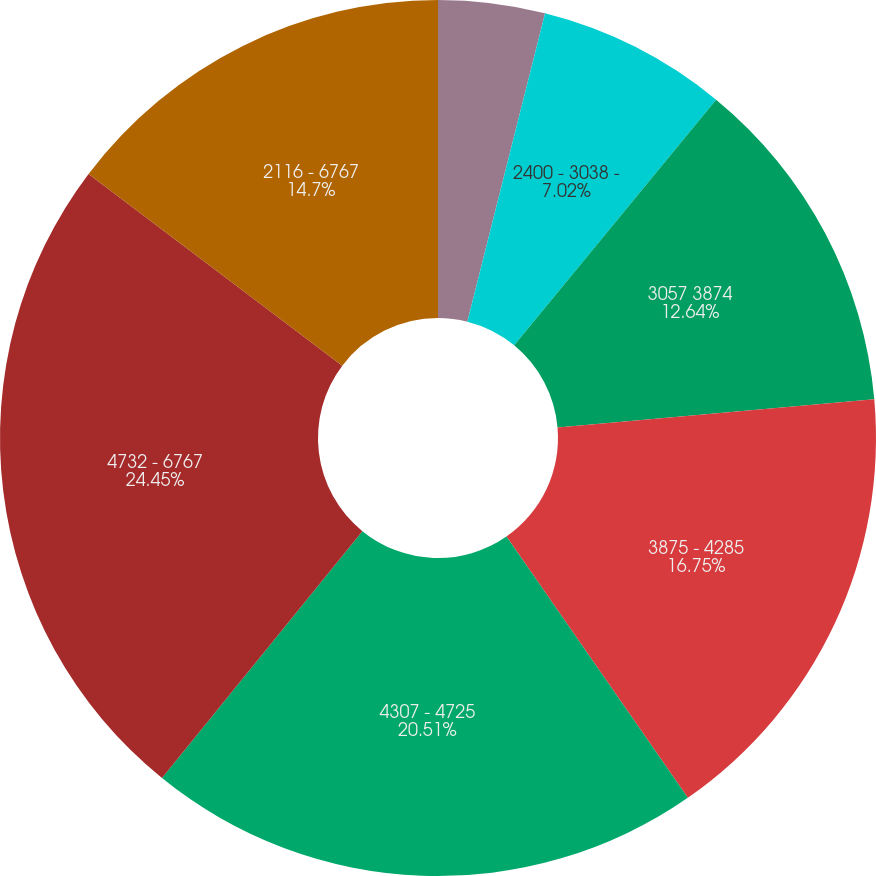<chart> <loc_0><loc_0><loc_500><loc_500><pie_chart><fcel>2116 - 2387<fcel>2400 - 3038 -<fcel>3057 3874<fcel>3875 - 4285<fcel>4307 - 4725<fcel>4732 - 6767<fcel>2116 - 6767<nl><fcel>3.93%<fcel>7.02%<fcel>12.64%<fcel>16.75%<fcel>20.51%<fcel>24.45%<fcel>14.7%<nl></chart> 